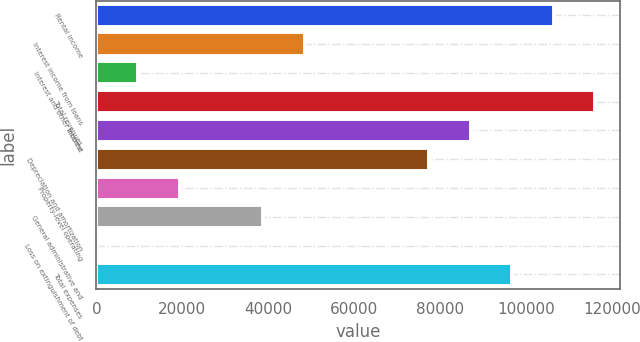Convert chart to OTSL. <chart><loc_0><loc_0><loc_500><loc_500><bar_chart><fcel>Rental income<fcel>Interest income from loans<fcel>Interest and other income<fcel>Total revenues<fcel>Interest<fcel>Depreciation and amortization<fcel>Property-level operating<fcel>General administrative and<fcel>Loss on extinguishment of debt<fcel>Total expenses<nl><fcel>106324<fcel>48385.5<fcel>9759.5<fcel>115981<fcel>87011.5<fcel>77355<fcel>19416<fcel>38729<fcel>103<fcel>96668<nl></chart> 